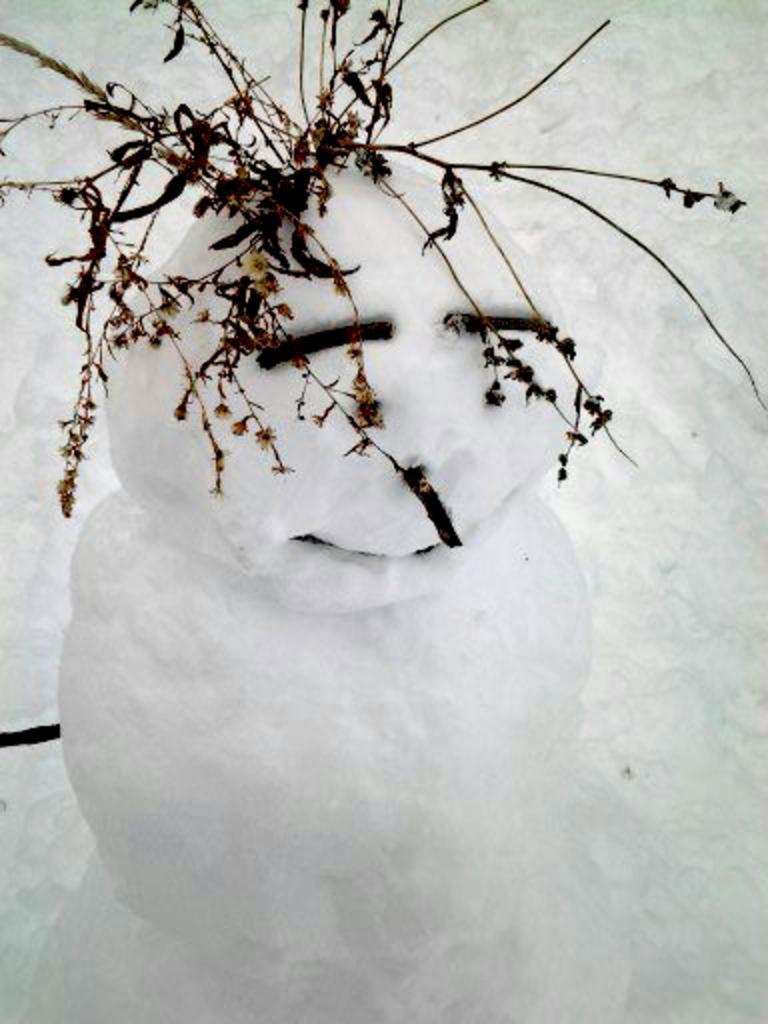How would you summarize this image in a sentence or two? In this picture there is a snowman. At the top we can see twigs. In the background there is snow. 